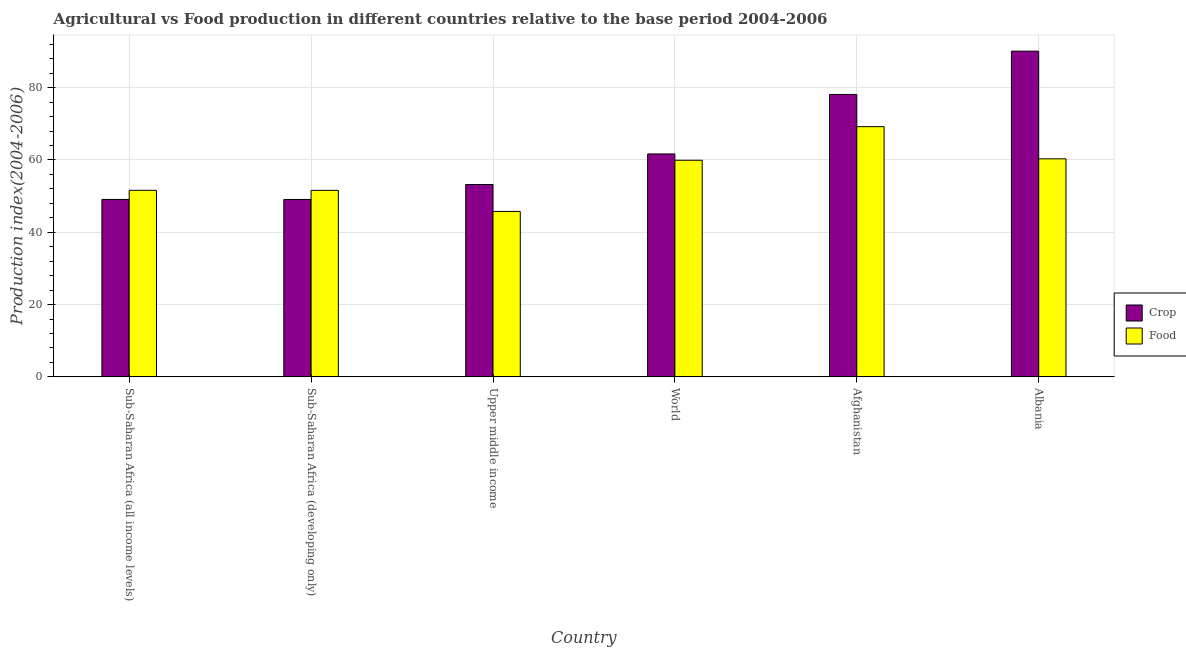How many different coloured bars are there?
Make the answer very short. 2. Are the number of bars on each tick of the X-axis equal?
Provide a short and direct response. Yes. How many bars are there on the 4th tick from the right?
Your answer should be compact. 2. What is the label of the 1st group of bars from the left?
Offer a terse response. Sub-Saharan Africa (all income levels). What is the food production index in Sub-Saharan Africa (developing only)?
Ensure brevity in your answer.  51.61. Across all countries, what is the maximum food production index?
Offer a terse response. 69.22. Across all countries, what is the minimum crop production index?
Make the answer very short. 49.08. In which country was the crop production index maximum?
Give a very brief answer. Albania. In which country was the crop production index minimum?
Offer a terse response. Sub-Saharan Africa (developing only). What is the total food production index in the graph?
Your answer should be very brief. 338.46. What is the difference between the crop production index in Sub-Saharan Africa (developing only) and that in Upper middle income?
Keep it short and to the point. -4.14. What is the difference between the food production index in Sub-Saharan Africa (all income levels) and the crop production index in World?
Offer a very short reply. -10.06. What is the average food production index per country?
Provide a succinct answer. 56.41. What is the difference between the crop production index and food production index in World?
Your answer should be very brief. 1.75. In how many countries, is the food production index greater than 4 ?
Give a very brief answer. 6. What is the ratio of the food production index in Afghanistan to that in Upper middle income?
Keep it short and to the point. 1.51. Is the food production index in Afghanistan less than that in Sub-Saharan Africa (all income levels)?
Provide a succinct answer. No. What is the difference between the highest and the second highest crop production index?
Your response must be concise. 11.97. What is the difference between the highest and the lowest food production index?
Ensure brevity in your answer.  23.45. In how many countries, is the crop production index greater than the average crop production index taken over all countries?
Ensure brevity in your answer.  2. What does the 1st bar from the left in World represents?
Your answer should be compact. Crop. What does the 1st bar from the right in Albania represents?
Your response must be concise. Food. Are all the bars in the graph horizontal?
Provide a short and direct response. No. Are the values on the major ticks of Y-axis written in scientific E-notation?
Provide a short and direct response. No. Does the graph contain any zero values?
Your answer should be compact. No. Does the graph contain grids?
Your answer should be very brief. Yes. What is the title of the graph?
Your answer should be very brief. Agricultural vs Food production in different countries relative to the base period 2004-2006. Does "Urban Population" appear as one of the legend labels in the graph?
Provide a short and direct response. No. What is the label or title of the Y-axis?
Your response must be concise. Production index(2004-2006). What is the Production index(2004-2006) in Crop in Sub-Saharan Africa (all income levels)?
Ensure brevity in your answer.  49.09. What is the Production index(2004-2006) in Food in Sub-Saharan Africa (all income levels)?
Offer a terse response. 51.61. What is the Production index(2004-2006) in Crop in Sub-Saharan Africa (developing only)?
Offer a terse response. 49.08. What is the Production index(2004-2006) of Food in Sub-Saharan Africa (developing only)?
Ensure brevity in your answer.  51.61. What is the Production index(2004-2006) of Crop in Upper middle income?
Ensure brevity in your answer.  53.22. What is the Production index(2004-2006) of Food in Upper middle income?
Ensure brevity in your answer.  45.77. What is the Production index(2004-2006) in Crop in World?
Your answer should be compact. 61.67. What is the Production index(2004-2006) in Food in World?
Offer a very short reply. 59.93. What is the Production index(2004-2006) in Crop in Afghanistan?
Your response must be concise. 78.14. What is the Production index(2004-2006) in Food in Afghanistan?
Provide a short and direct response. 69.22. What is the Production index(2004-2006) in Crop in Albania?
Make the answer very short. 90.11. What is the Production index(2004-2006) of Food in Albania?
Provide a short and direct response. 60.32. Across all countries, what is the maximum Production index(2004-2006) of Crop?
Offer a terse response. 90.11. Across all countries, what is the maximum Production index(2004-2006) of Food?
Offer a terse response. 69.22. Across all countries, what is the minimum Production index(2004-2006) of Crop?
Your answer should be very brief. 49.08. Across all countries, what is the minimum Production index(2004-2006) of Food?
Ensure brevity in your answer.  45.77. What is the total Production index(2004-2006) of Crop in the graph?
Offer a very short reply. 381.32. What is the total Production index(2004-2006) in Food in the graph?
Make the answer very short. 338.46. What is the difference between the Production index(2004-2006) in Crop in Sub-Saharan Africa (all income levels) and that in Sub-Saharan Africa (developing only)?
Offer a terse response. 0.01. What is the difference between the Production index(2004-2006) in Food in Sub-Saharan Africa (all income levels) and that in Sub-Saharan Africa (developing only)?
Give a very brief answer. 0.01. What is the difference between the Production index(2004-2006) of Crop in Sub-Saharan Africa (all income levels) and that in Upper middle income?
Give a very brief answer. -4.13. What is the difference between the Production index(2004-2006) in Food in Sub-Saharan Africa (all income levels) and that in Upper middle income?
Your answer should be very brief. 5.84. What is the difference between the Production index(2004-2006) in Crop in Sub-Saharan Africa (all income levels) and that in World?
Give a very brief answer. -12.58. What is the difference between the Production index(2004-2006) of Food in Sub-Saharan Africa (all income levels) and that in World?
Your response must be concise. -8.31. What is the difference between the Production index(2004-2006) in Crop in Sub-Saharan Africa (all income levels) and that in Afghanistan?
Your answer should be very brief. -29.05. What is the difference between the Production index(2004-2006) of Food in Sub-Saharan Africa (all income levels) and that in Afghanistan?
Your answer should be very brief. -17.61. What is the difference between the Production index(2004-2006) in Crop in Sub-Saharan Africa (all income levels) and that in Albania?
Ensure brevity in your answer.  -41.02. What is the difference between the Production index(2004-2006) of Food in Sub-Saharan Africa (all income levels) and that in Albania?
Ensure brevity in your answer.  -8.71. What is the difference between the Production index(2004-2006) of Crop in Sub-Saharan Africa (developing only) and that in Upper middle income?
Ensure brevity in your answer.  -4.14. What is the difference between the Production index(2004-2006) in Food in Sub-Saharan Africa (developing only) and that in Upper middle income?
Your answer should be compact. 5.84. What is the difference between the Production index(2004-2006) in Crop in Sub-Saharan Africa (developing only) and that in World?
Your answer should be compact. -12.59. What is the difference between the Production index(2004-2006) of Food in Sub-Saharan Africa (developing only) and that in World?
Make the answer very short. -8.32. What is the difference between the Production index(2004-2006) in Crop in Sub-Saharan Africa (developing only) and that in Afghanistan?
Keep it short and to the point. -29.06. What is the difference between the Production index(2004-2006) in Food in Sub-Saharan Africa (developing only) and that in Afghanistan?
Your answer should be very brief. -17.61. What is the difference between the Production index(2004-2006) of Crop in Sub-Saharan Africa (developing only) and that in Albania?
Provide a succinct answer. -41.03. What is the difference between the Production index(2004-2006) of Food in Sub-Saharan Africa (developing only) and that in Albania?
Offer a terse response. -8.71. What is the difference between the Production index(2004-2006) of Crop in Upper middle income and that in World?
Your answer should be compact. -8.45. What is the difference between the Production index(2004-2006) in Food in Upper middle income and that in World?
Provide a short and direct response. -14.16. What is the difference between the Production index(2004-2006) in Crop in Upper middle income and that in Afghanistan?
Make the answer very short. -24.92. What is the difference between the Production index(2004-2006) of Food in Upper middle income and that in Afghanistan?
Provide a short and direct response. -23.45. What is the difference between the Production index(2004-2006) in Crop in Upper middle income and that in Albania?
Offer a terse response. -36.89. What is the difference between the Production index(2004-2006) of Food in Upper middle income and that in Albania?
Ensure brevity in your answer.  -14.55. What is the difference between the Production index(2004-2006) of Crop in World and that in Afghanistan?
Your answer should be compact. -16.47. What is the difference between the Production index(2004-2006) of Food in World and that in Afghanistan?
Offer a terse response. -9.29. What is the difference between the Production index(2004-2006) of Crop in World and that in Albania?
Offer a terse response. -28.44. What is the difference between the Production index(2004-2006) in Food in World and that in Albania?
Provide a succinct answer. -0.39. What is the difference between the Production index(2004-2006) in Crop in Afghanistan and that in Albania?
Your answer should be very brief. -11.97. What is the difference between the Production index(2004-2006) in Food in Afghanistan and that in Albania?
Your answer should be very brief. 8.9. What is the difference between the Production index(2004-2006) of Crop in Sub-Saharan Africa (all income levels) and the Production index(2004-2006) of Food in Sub-Saharan Africa (developing only)?
Ensure brevity in your answer.  -2.52. What is the difference between the Production index(2004-2006) of Crop in Sub-Saharan Africa (all income levels) and the Production index(2004-2006) of Food in Upper middle income?
Provide a succinct answer. 3.32. What is the difference between the Production index(2004-2006) of Crop in Sub-Saharan Africa (all income levels) and the Production index(2004-2006) of Food in World?
Your response must be concise. -10.83. What is the difference between the Production index(2004-2006) in Crop in Sub-Saharan Africa (all income levels) and the Production index(2004-2006) in Food in Afghanistan?
Keep it short and to the point. -20.13. What is the difference between the Production index(2004-2006) of Crop in Sub-Saharan Africa (all income levels) and the Production index(2004-2006) of Food in Albania?
Your answer should be very brief. -11.23. What is the difference between the Production index(2004-2006) of Crop in Sub-Saharan Africa (developing only) and the Production index(2004-2006) of Food in Upper middle income?
Make the answer very short. 3.31. What is the difference between the Production index(2004-2006) of Crop in Sub-Saharan Africa (developing only) and the Production index(2004-2006) of Food in World?
Give a very brief answer. -10.85. What is the difference between the Production index(2004-2006) of Crop in Sub-Saharan Africa (developing only) and the Production index(2004-2006) of Food in Afghanistan?
Provide a succinct answer. -20.14. What is the difference between the Production index(2004-2006) in Crop in Sub-Saharan Africa (developing only) and the Production index(2004-2006) in Food in Albania?
Keep it short and to the point. -11.24. What is the difference between the Production index(2004-2006) of Crop in Upper middle income and the Production index(2004-2006) of Food in World?
Keep it short and to the point. -6.71. What is the difference between the Production index(2004-2006) of Crop in Upper middle income and the Production index(2004-2006) of Food in Afghanistan?
Give a very brief answer. -16. What is the difference between the Production index(2004-2006) in Crop in Upper middle income and the Production index(2004-2006) in Food in Albania?
Give a very brief answer. -7.1. What is the difference between the Production index(2004-2006) of Crop in World and the Production index(2004-2006) of Food in Afghanistan?
Offer a terse response. -7.55. What is the difference between the Production index(2004-2006) in Crop in World and the Production index(2004-2006) in Food in Albania?
Make the answer very short. 1.35. What is the difference between the Production index(2004-2006) in Crop in Afghanistan and the Production index(2004-2006) in Food in Albania?
Provide a succinct answer. 17.82. What is the average Production index(2004-2006) of Crop per country?
Ensure brevity in your answer.  63.55. What is the average Production index(2004-2006) of Food per country?
Make the answer very short. 56.41. What is the difference between the Production index(2004-2006) of Crop and Production index(2004-2006) of Food in Sub-Saharan Africa (all income levels)?
Make the answer very short. -2.52. What is the difference between the Production index(2004-2006) in Crop and Production index(2004-2006) in Food in Sub-Saharan Africa (developing only)?
Your answer should be compact. -2.53. What is the difference between the Production index(2004-2006) of Crop and Production index(2004-2006) of Food in Upper middle income?
Offer a very short reply. 7.45. What is the difference between the Production index(2004-2006) in Crop and Production index(2004-2006) in Food in World?
Offer a very short reply. 1.75. What is the difference between the Production index(2004-2006) of Crop and Production index(2004-2006) of Food in Afghanistan?
Provide a short and direct response. 8.92. What is the difference between the Production index(2004-2006) in Crop and Production index(2004-2006) in Food in Albania?
Offer a terse response. 29.79. What is the ratio of the Production index(2004-2006) of Crop in Sub-Saharan Africa (all income levels) to that in Sub-Saharan Africa (developing only)?
Provide a succinct answer. 1. What is the ratio of the Production index(2004-2006) in Food in Sub-Saharan Africa (all income levels) to that in Sub-Saharan Africa (developing only)?
Give a very brief answer. 1. What is the ratio of the Production index(2004-2006) in Crop in Sub-Saharan Africa (all income levels) to that in Upper middle income?
Ensure brevity in your answer.  0.92. What is the ratio of the Production index(2004-2006) in Food in Sub-Saharan Africa (all income levels) to that in Upper middle income?
Make the answer very short. 1.13. What is the ratio of the Production index(2004-2006) in Crop in Sub-Saharan Africa (all income levels) to that in World?
Provide a short and direct response. 0.8. What is the ratio of the Production index(2004-2006) of Food in Sub-Saharan Africa (all income levels) to that in World?
Ensure brevity in your answer.  0.86. What is the ratio of the Production index(2004-2006) of Crop in Sub-Saharan Africa (all income levels) to that in Afghanistan?
Your answer should be very brief. 0.63. What is the ratio of the Production index(2004-2006) of Food in Sub-Saharan Africa (all income levels) to that in Afghanistan?
Make the answer very short. 0.75. What is the ratio of the Production index(2004-2006) of Crop in Sub-Saharan Africa (all income levels) to that in Albania?
Your response must be concise. 0.54. What is the ratio of the Production index(2004-2006) in Food in Sub-Saharan Africa (all income levels) to that in Albania?
Provide a succinct answer. 0.86. What is the ratio of the Production index(2004-2006) in Crop in Sub-Saharan Africa (developing only) to that in Upper middle income?
Make the answer very short. 0.92. What is the ratio of the Production index(2004-2006) in Food in Sub-Saharan Africa (developing only) to that in Upper middle income?
Offer a very short reply. 1.13. What is the ratio of the Production index(2004-2006) of Crop in Sub-Saharan Africa (developing only) to that in World?
Ensure brevity in your answer.  0.8. What is the ratio of the Production index(2004-2006) in Food in Sub-Saharan Africa (developing only) to that in World?
Your response must be concise. 0.86. What is the ratio of the Production index(2004-2006) in Crop in Sub-Saharan Africa (developing only) to that in Afghanistan?
Provide a succinct answer. 0.63. What is the ratio of the Production index(2004-2006) of Food in Sub-Saharan Africa (developing only) to that in Afghanistan?
Give a very brief answer. 0.75. What is the ratio of the Production index(2004-2006) of Crop in Sub-Saharan Africa (developing only) to that in Albania?
Give a very brief answer. 0.54. What is the ratio of the Production index(2004-2006) in Food in Sub-Saharan Africa (developing only) to that in Albania?
Your answer should be very brief. 0.86. What is the ratio of the Production index(2004-2006) of Crop in Upper middle income to that in World?
Offer a terse response. 0.86. What is the ratio of the Production index(2004-2006) in Food in Upper middle income to that in World?
Provide a succinct answer. 0.76. What is the ratio of the Production index(2004-2006) of Crop in Upper middle income to that in Afghanistan?
Make the answer very short. 0.68. What is the ratio of the Production index(2004-2006) in Food in Upper middle income to that in Afghanistan?
Provide a short and direct response. 0.66. What is the ratio of the Production index(2004-2006) of Crop in Upper middle income to that in Albania?
Offer a terse response. 0.59. What is the ratio of the Production index(2004-2006) in Food in Upper middle income to that in Albania?
Offer a very short reply. 0.76. What is the ratio of the Production index(2004-2006) of Crop in World to that in Afghanistan?
Offer a very short reply. 0.79. What is the ratio of the Production index(2004-2006) in Food in World to that in Afghanistan?
Ensure brevity in your answer.  0.87. What is the ratio of the Production index(2004-2006) in Crop in World to that in Albania?
Your answer should be compact. 0.68. What is the ratio of the Production index(2004-2006) of Crop in Afghanistan to that in Albania?
Provide a succinct answer. 0.87. What is the ratio of the Production index(2004-2006) of Food in Afghanistan to that in Albania?
Provide a succinct answer. 1.15. What is the difference between the highest and the second highest Production index(2004-2006) of Crop?
Make the answer very short. 11.97. What is the difference between the highest and the second highest Production index(2004-2006) in Food?
Offer a terse response. 8.9. What is the difference between the highest and the lowest Production index(2004-2006) of Crop?
Provide a succinct answer. 41.03. What is the difference between the highest and the lowest Production index(2004-2006) in Food?
Your answer should be compact. 23.45. 